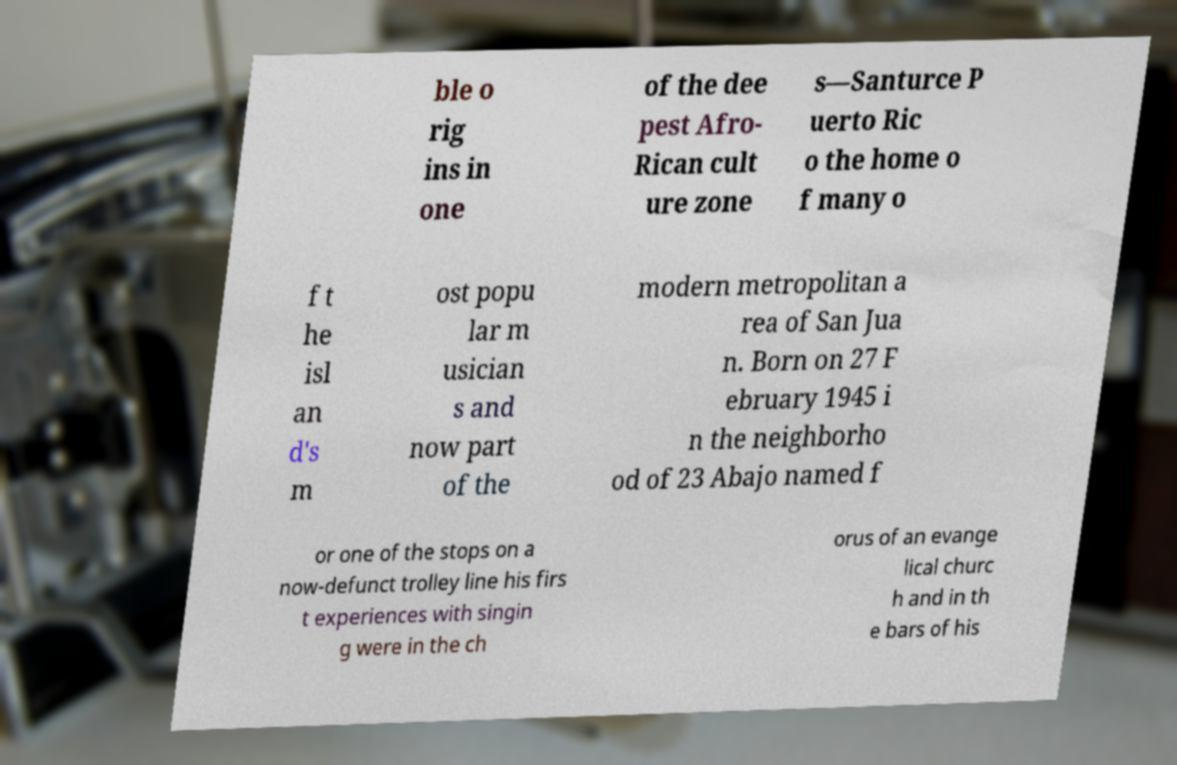Can you read and provide the text displayed in the image?This photo seems to have some interesting text. Can you extract and type it out for me? ble o rig ins in one of the dee pest Afro- Rican cult ure zone s—Santurce P uerto Ric o the home o f many o f t he isl an d's m ost popu lar m usician s and now part of the modern metropolitan a rea of San Jua n. Born on 27 F ebruary 1945 i n the neighborho od of 23 Abajo named f or one of the stops on a now-defunct trolley line his firs t experiences with singin g were in the ch orus of an evange lical churc h and in th e bars of his 